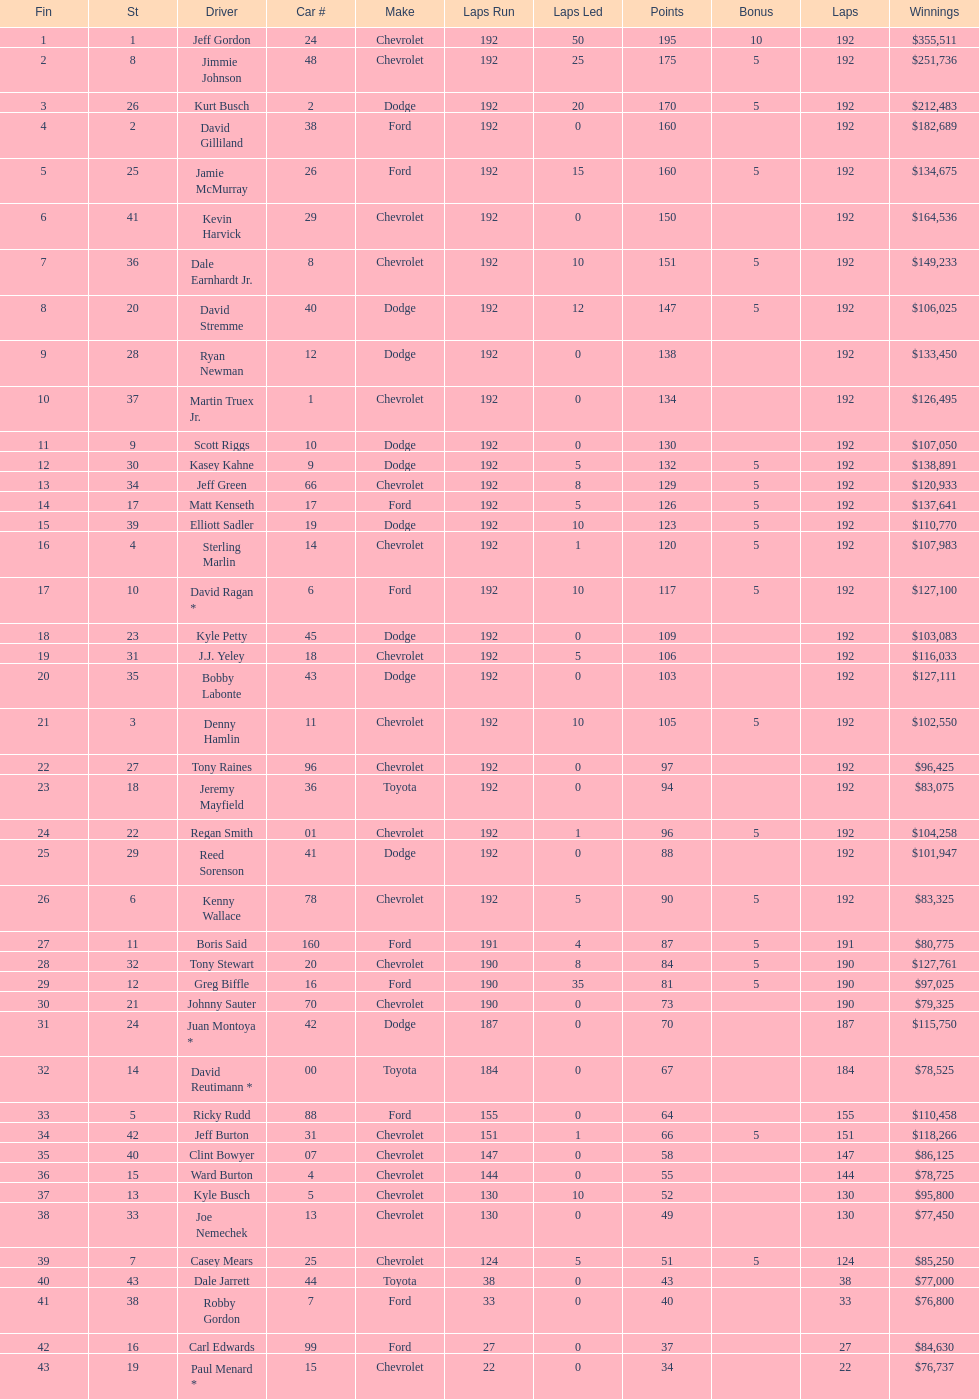How many drivers placed below tony stewart? 15. Could you parse the entire table? {'header': ['Fin', 'St', 'Driver', 'Car #', 'Make', 'Laps Run', 'Laps Led', 'Points', 'Bonus', 'Laps', 'Winnings'], 'rows': [['1', '1', 'Jeff Gordon', '24', 'Chevrolet', '192', '50', '195', '10', '192', '$355,511'], ['2', '8', 'Jimmie Johnson', '48', 'Chevrolet', '192', '25', '175', '5', '192', '$251,736'], ['3', '26', 'Kurt Busch', '2', 'Dodge', '192', '20', '170', '5', '192', '$212,483'], ['4', '2', 'David Gilliland', '38', 'Ford', '192', '0', '160', '', '192', '$182,689'], ['5', '25', 'Jamie McMurray', '26', 'Ford', '192', '15', '160', '5', '192', '$134,675'], ['6', '41', 'Kevin Harvick', '29', 'Chevrolet', '192', '0', '150', '', '192', '$164,536'], ['7', '36', 'Dale Earnhardt Jr.', '8', 'Chevrolet', '192', '10', '151', '5', '192', '$149,233'], ['8', '20', 'David Stremme', '40', 'Dodge', '192', '12', '147', '5', '192', '$106,025'], ['9', '28', 'Ryan Newman', '12', 'Dodge', '192', '0', '138', '', '192', '$133,450'], ['10', '37', 'Martin Truex Jr.', '1', 'Chevrolet', '192', '0', '134', '', '192', '$126,495'], ['11', '9', 'Scott Riggs', '10', 'Dodge', '192', '0', '130', '', '192', '$107,050'], ['12', '30', 'Kasey Kahne', '9', 'Dodge', '192', '5', '132', '5', '192', '$138,891'], ['13', '34', 'Jeff Green', '66', 'Chevrolet', '192', '8', '129', '5', '192', '$120,933'], ['14', '17', 'Matt Kenseth', '17', 'Ford', '192', '5', '126', '5', '192', '$137,641'], ['15', '39', 'Elliott Sadler', '19', 'Dodge', '192', '10', '123', '5', '192', '$110,770'], ['16', '4', 'Sterling Marlin', '14', 'Chevrolet', '192', '1', '120', '5', '192', '$107,983'], ['17', '10', 'David Ragan *', '6', 'Ford', '192', '10', '117', '5', '192', '$127,100'], ['18', '23', 'Kyle Petty', '45', 'Dodge', '192', '0', '109', '', '192', '$103,083'], ['19', '31', 'J.J. Yeley', '18', 'Chevrolet', '192', '5', '106', '', '192', '$116,033'], ['20', '35', 'Bobby Labonte', '43', 'Dodge', '192', '0', '103', '', '192', '$127,111'], ['21', '3', 'Denny Hamlin', '11', 'Chevrolet', '192', '10', '105', '5', '192', '$102,550'], ['22', '27', 'Tony Raines', '96', 'Chevrolet', '192', '0', '97', '', '192', '$96,425'], ['23', '18', 'Jeremy Mayfield', '36', 'Toyota', '192', '0', '94', '', '192', '$83,075'], ['24', '22', 'Regan Smith', '01', 'Chevrolet', '192', '1', '96', '5', '192', '$104,258'], ['25', '29', 'Reed Sorenson', '41', 'Dodge', '192', '0', '88', '', '192', '$101,947'], ['26', '6', 'Kenny Wallace', '78', 'Chevrolet', '192', '5', '90', '5', '192', '$83,325'], ['27', '11', 'Boris Said', '160', 'Ford', '191', '4', '87', '5', '191', '$80,775'], ['28', '32', 'Tony Stewart', '20', 'Chevrolet', '190', '8', '84', '5', '190', '$127,761'], ['29', '12', 'Greg Biffle', '16', 'Ford', '190', '35', '81', '5', '190', '$97,025'], ['30', '21', 'Johnny Sauter', '70', 'Chevrolet', '190', '0', '73', '', '190', '$79,325'], ['31', '24', 'Juan Montoya *', '42', 'Dodge', '187', '0', '70', '', '187', '$115,750'], ['32', '14', 'David Reutimann *', '00', 'Toyota', '184', '0', '67', '', '184', '$78,525'], ['33', '5', 'Ricky Rudd', '88', 'Ford', '155', '0', '64', '', '155', '$110,458'], ['34', '42', 'Jeff Burton', '31', 'Chevrolet', '151', '1', '66', '5', '151', '$118,266'], ['35', '40', 'Clint Bowyer', '07', 'Chevrolet', '147', '0', '58', '', '147', '$86,125'], ['36', '15', 'Ward Burton', '4', 'Chevrolet', '144', '0', '55', '', '144', '$78,725'], ['37', '13', 'Kyle Busch', '5', 'Chevrolet', '130', '10', '52', '', '130', '$95,800'], ['38', '33', 'Joe Nemechek', '13', 'Chevrolet', '130', '0', '49', '', '130', '$77,450'], ['39', '7', 'Casey Mears', '25', 'Chevrolet', '124', '5', '51', '5', '124', '$85,250'], ['40', '43', 'Dale Jarrett', '44', 'Toyota', '38', '0', '43', '', '38', '$77,000'], ['41', '38', 'Robby Gordon', '7', 'Ford', '33', '0', '40', '', '33', '$76,800'], ['42', '16', 'Carl Edwards', '99', 'Ford', '27', '0', '37', '', '27', '$84,630'], ['43', '19', 'Paul Menard *', '15', 'Chevrolet', '22', '0', '34', '', '22', '$76,737']]} 